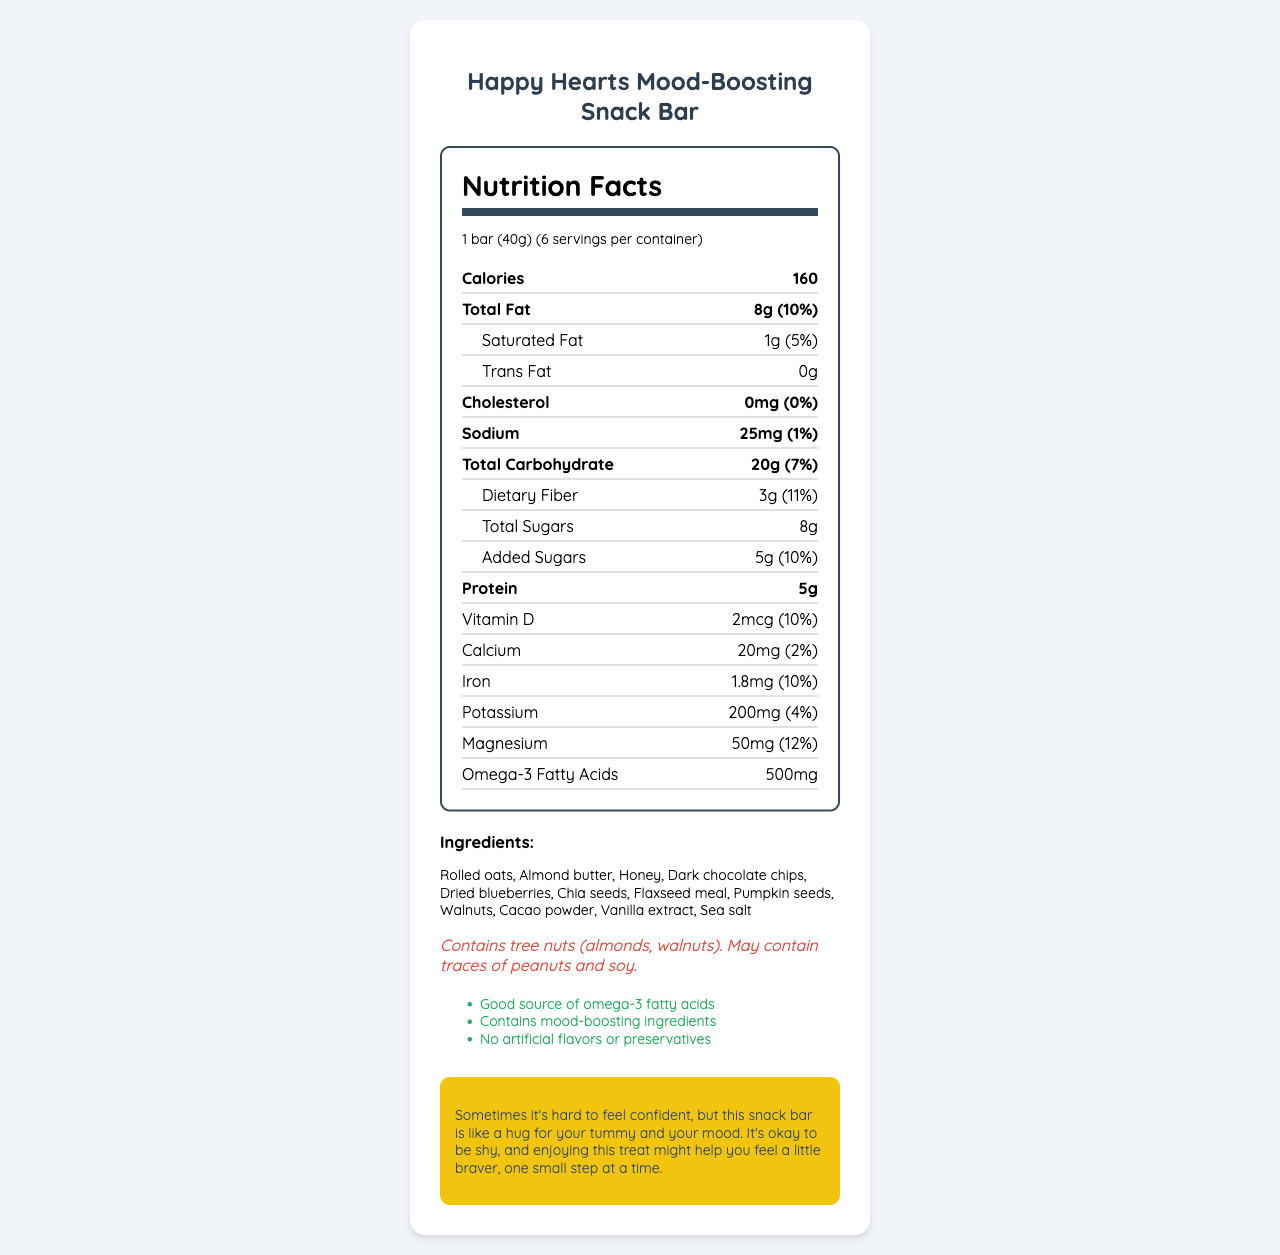what is the serving size? The serving size is clearly stated in the document as "1 bar (40g)".
Answer: 1 bar (40g) how many servings are in one container? The document mentions there are "6 servings per container".
Answer: 6 how many calories are in one serving? The calories per serving are listed as 160.
Answer: 160 what is the amount of dietary fiber in one serving? The document states that there are 3g of dietary fiber per serving.
Answer: 3g which nuts are mentioned as allergens in the snack bar? The allergen info states that the bar contains tree nuts (almonds, walnuts).
Answer: Almonds and walnuts how much protein is in one bar? The nutrition label indicates that each bar has 5g of protein.
Answer: 5g which of the following ingredients is not in the snack bar? A. Rolled oats B. Honey C. White chocolate chips D. Dark chocolate chips The ingredients list includes rolled oats, honey, and dark chocolate chips, but not white chocolate chips.
Answer: C what percentage of the daily value of magnesium does one bar provide? A. 10% B. 12% C. 15% D. 20% The document states that the magnesium amount is 50mg, which is 12% of the daily value.
Answer: B does this snack bar contain any cholesterol? The nutrition label shows 0mg of cholesterol, meaning the bar contains no cholesterol.
Answer: No is there any trans fat in the snack bar? The document clearly mentions that there are 0g of trans fat.
Answer: No what's the main purpose of the shy child message in the document? The shy child message is designed to provide emotional support by likening the snack bar to a comforting, mood-boosting treat.
Answer: To offer empathy and encouragement summarize the key nutritional information provided in the document. The summary includes the core nutritional details of the snack bar, relevant health benefits, and special claims about mood enhancement, encapsulating the essential aspects of the document.
Answer: The Happy Hearts Mood-Boosting Snack Bar has 160 calories per serving (1 bar/40g), with noteworthy contents like 8g of total fat, 20g of carbohydrates, 3g of dietary fiber, 8g of total sugars (5g added), and 5g of protein. The bar is fortified with various vitamins and minerals, including 10% daily value of Vitamin D, 10% iron, and 12% magnesium. It contains mood-boosting ingredients and is free from artificial flavors and preservatives. what is the omega-3 fatty acids content of the snack bar? The document lists the omega-3 fatty acids content as 500mg.
Answer: 500mg what is the main sweetener used in the snack bar? The ingredients list clearly mentions honey as one of the components.
Answer: Honey what is the main mineral included in the highest percentage of the daily value? Magnesium is included at 12% of the daily value, which is the highest percentage of any mineral listed.
Answer: Magnesium is the snack bar good for people who are allergic to soy? The document only mentions that the bar "may contain traces of peanuts and soy" but does not provide definitive information about its safety for those allergic to soy.
Answer: Cannot be determined 